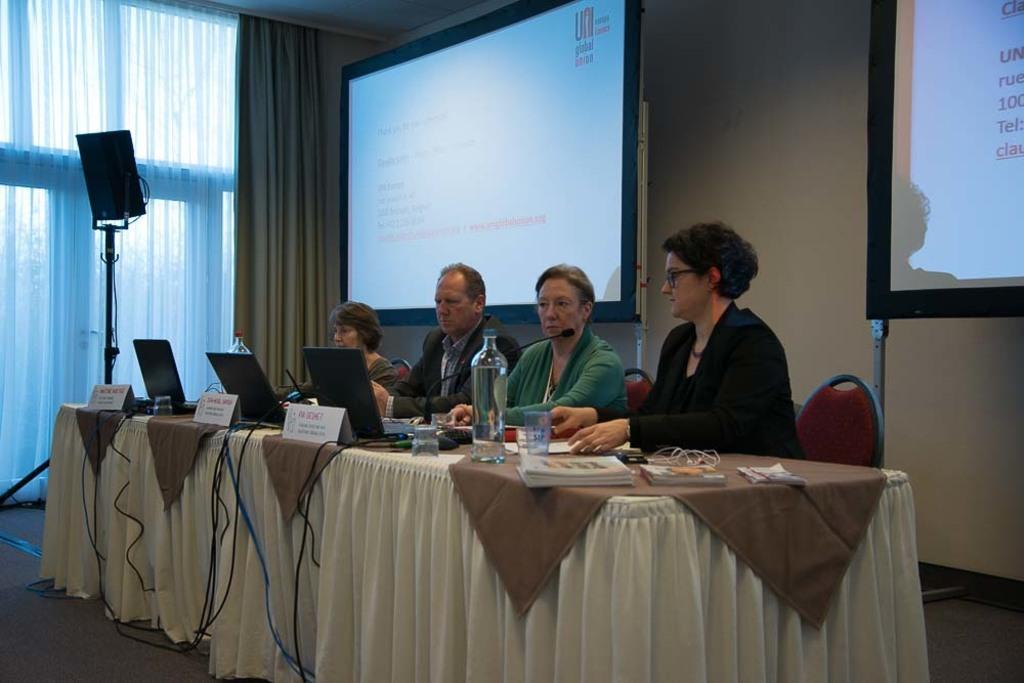How would you summarize this image in a sentence or two? In this image there are four people sitting on the chair, there is a table, there are three laptops on the table,there is a bottle on the table, there is a glass on the table, there are books on the table,there is a projector screen. 